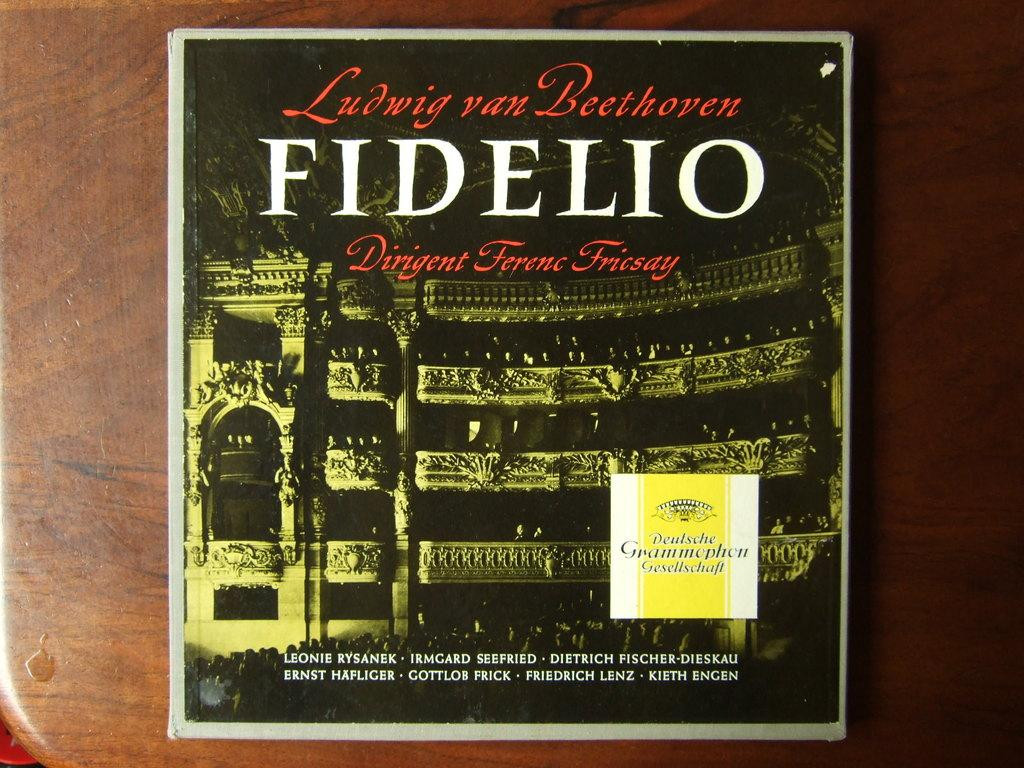<image>
Present a compact description of the photo's key features. An album on a table shows Beethoven's name in front of a building. 